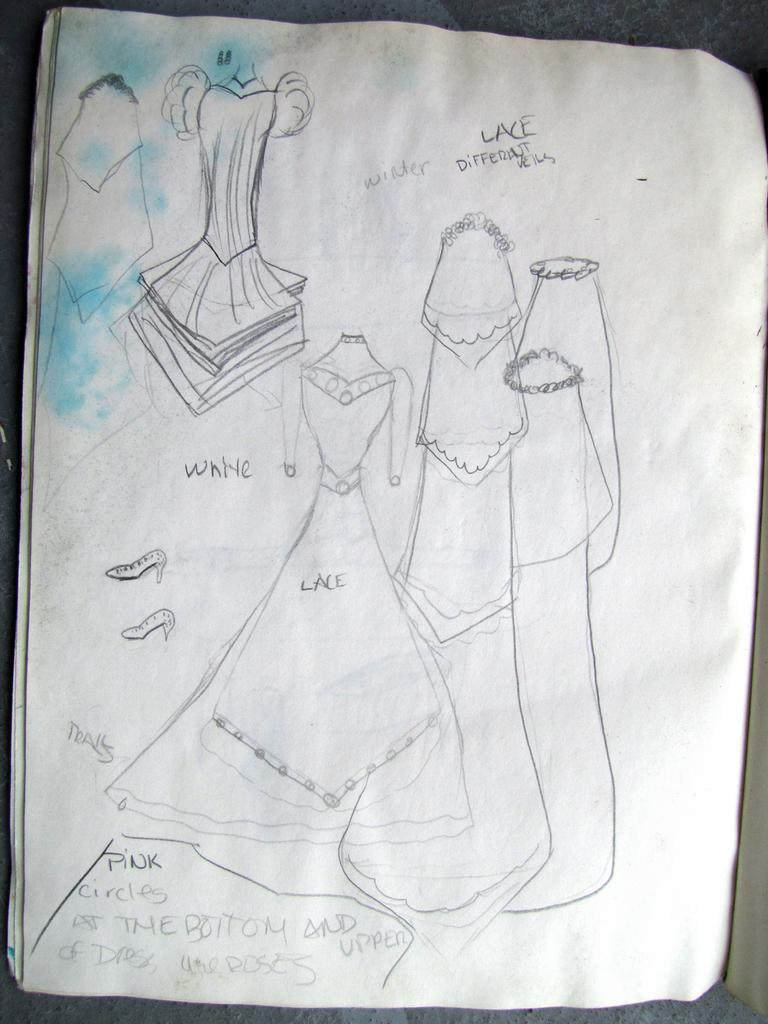What is present on the paper in the image? There is a sketch and text written on the paper. Can you describe the sketch on the paper? Unfortunately, the details of the sketch cannot be determined from the image alone. What type of content is written on the paper? The text written on the paper cannot be determined from the image alone. What country is depicted in the sketch on the paper? There is no country depicted in the sketch on the paper, as the details of the sketch cannot be determined from the image alone. 